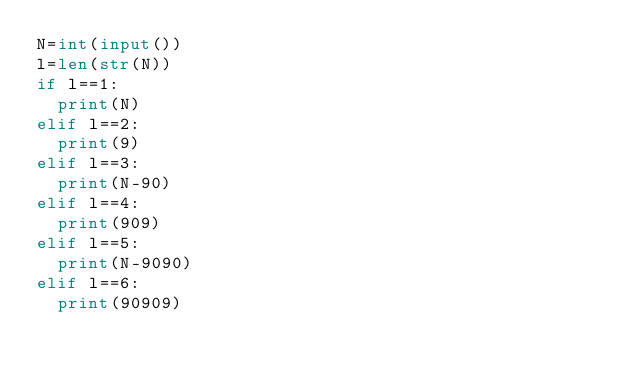<code> <loc_0><loc_0><loc_500><loc_500><_Python_>N=int(input())
l=len(str(N))
if l==1:
  print(N)
elif l==2:
  print(9)
elif l==3:
  print(N-90)
elif l==4:
  print(909)
elif l==5:
  print(N-9090)
elif l==6:
  print(90909)</code> 